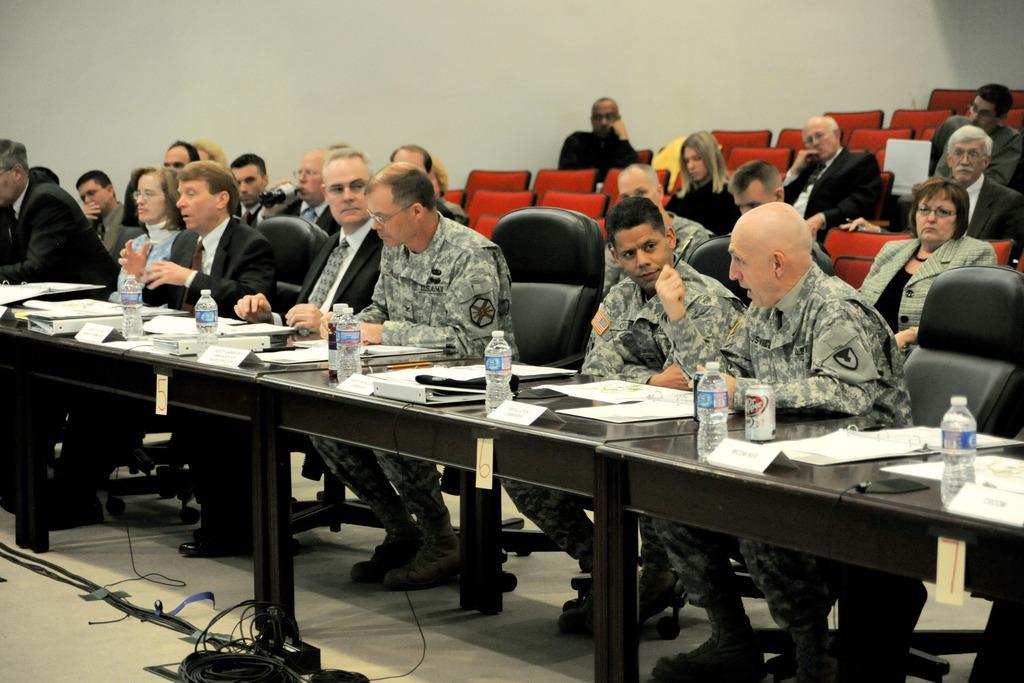How would you summarize this image in a sentence or two? There are group of people sitting on the chairs. This is a table with papers,filed,water bottles,name board and some other objects. This looks like a number written on the paper. At bottom of the image I can see cable. At background I can see some red empty chairs. 